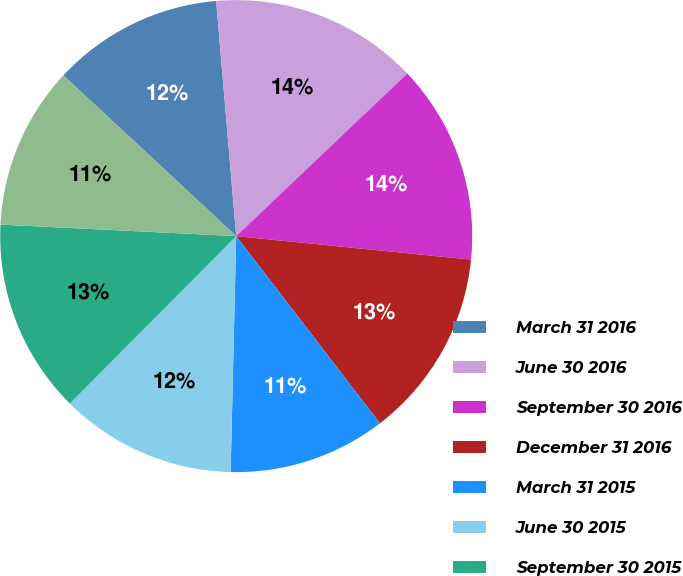Convert chart. <chart><loc_0><loc_0><loc_500><loc_500><pie_chart><fcel>March 31 2016<fcel>June 30 2016<fcel>September 30 2016<fcel>December 31 2016<fcel>March 31 2015<fcel>June 30 2015<fcel>September 30 2015<fcel>December 31 2015<nl><fcel>11.72%<fcel>14.26%<fcel>13.68%<fcel>12.99%<fcel>10.8%<fcel>12.07%<fcel>13.33%<fcel>11.15%<nl></chart> 